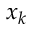Convert formula to latex. <formula><loc_0><loc_0><loc_500><loc_500>x _ { k }</formula> 